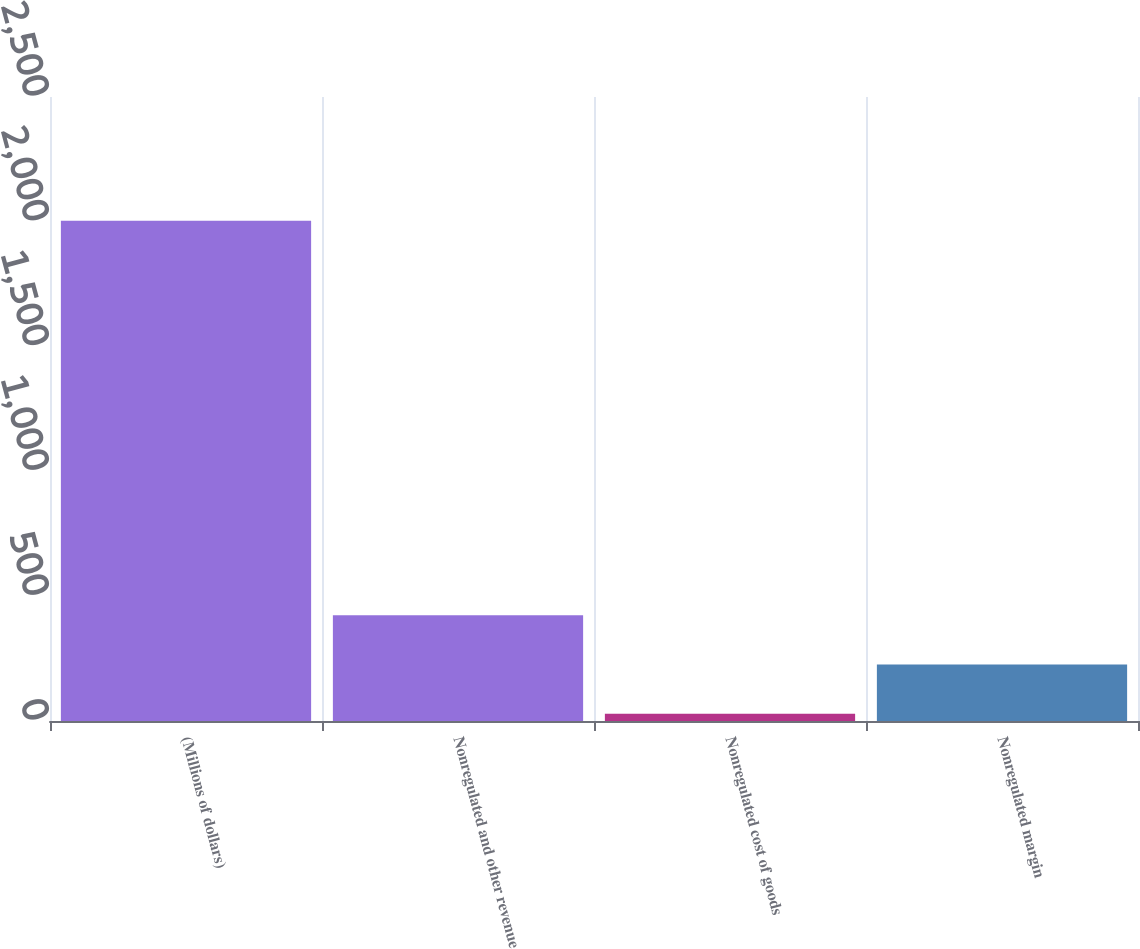<chart> <loc_0><loc_0><loc_500><loc_500><bar_chart><fcel>(Millions of dollars)<fcel>Nonregulated and other revenue<fcel>Nonregulated cost of goods<fcel>Nonregulated margin<nl><fcel>2004<fcel>424<fcel>29<fcel>226.5<nl></chart> 